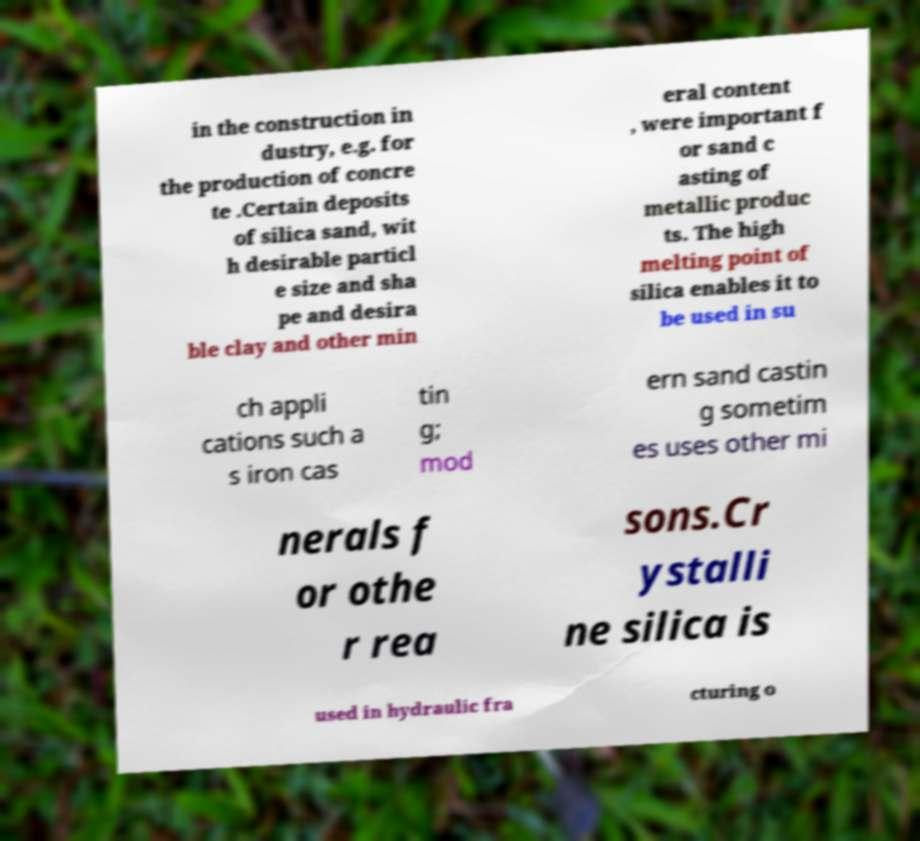Could you assist in decoding the text presented in this image and type it out clearly? in the construction in dustry, e.g. for the production of concre te .Certain deposits of silica sand, wit h desirable particl e size and sha pe and desira ble clay and other min eral content , were important f or sand c asting of metallic produc ts. The high melting point of silica enables it to be used in su ch appli cations such a s iron cas tin g; mod ern sand castin g sometim es uses other mi nerals f or othe r rea sons.Cr ystalli ne silica is used in hydraulic fra cturing o 